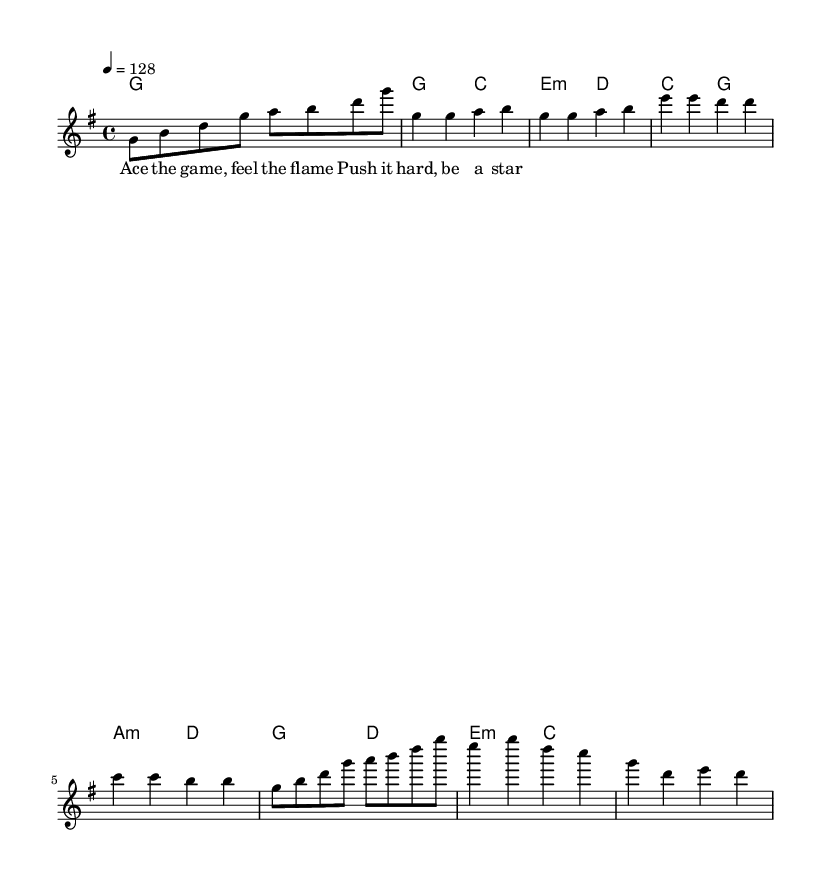what is the key signature of this music? The key signature is written as G major, which includes one sharp (F#). You can determine this by visually inspecting the key signature area at the beginning of the sheet music.
Answer: G major what is the time signature of the music? The time signature is 4/4, indicated at the beginning of the sheet music. This means there are four beats per measure and the quarter note gets one beat.
Answer: 4/4 what is the tempo marking of the song? The tempo marking shows a speed of 128 beats per minute. It is indicated by the tempo instruction at the beginning of the music, which specifies the pace of the piece.
Answer: 128 how many measures are in the chorus section? The chorus section contains four measures based on the layout seen in the sheet music. By counting the measures under the chorus segment, we find a total of four distinct measures.
Answer: 4 what is the main theme expressed in the lyrics? The lyrics represent a motivational theme related to sports and achievement, emphasizing pushing oneself and striving to shine. Analyzing the chorus lyrics highlights the sports context, portraying movement and success.
Answer: Motivation which musical form does this song primarily demonstrate? The song primarily demonstrates a verse-chorus form, as seen in the arrangement of sections where verses are followed by a repeated chorus. This common structure is recognizable and is typical in K-Pop music.
Answer: Verse-Chorus what type of harmonies are used in the pre-chorus? The pre-chorus features minor and major harmonies. Specifically, you can see the chord notations indicating the use of minor (a minor) and major chords (C and G), which contribute to a contrasting emotional build-up.
Answer: Minor and Major 